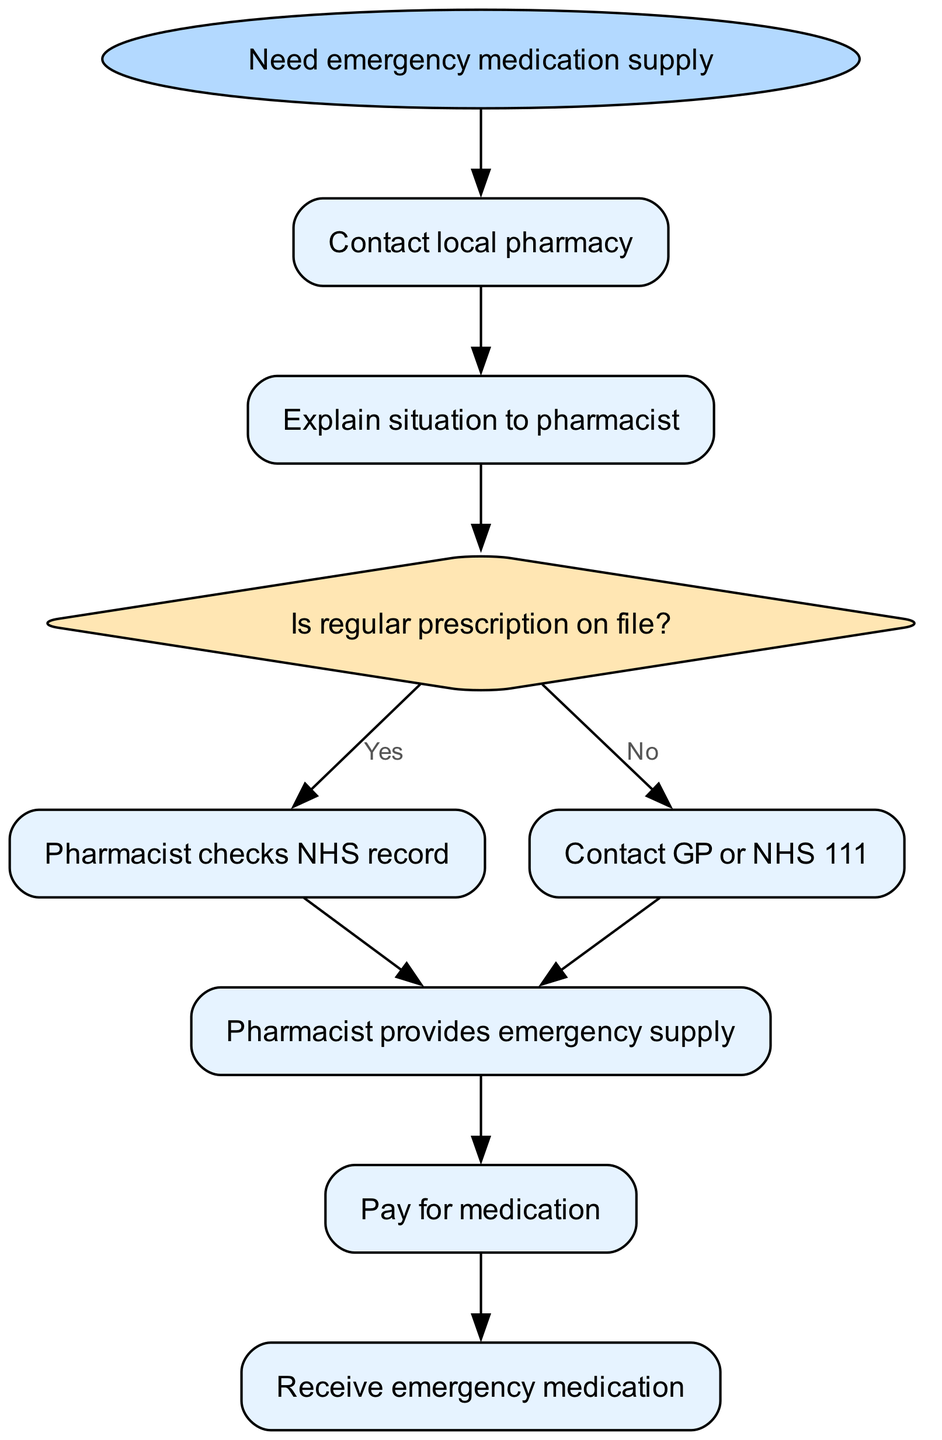What is the first step to take when needing an emergency medication supply? The first step in the diagram is represented by the "Need emergency medication supply" node. From this node, the next action is to "Contact local pharmacy."
Answer: Contact local pharmacy What type of shape represents a decision in the flow chart? In the flow chart, decisions are represented by diamond-shaped nodes, specifically labeled as "decision." In this case, the decision node is "Is regular prescription on file?"
Answer: Diamond How many steps are there in the process to obtain emergency medication? The process consists of six steps, starting from "Contact local pharmacy" and ending at "Pay for medication," followed by the final step "Receive emergency medication."
Answer: Six What action occurs if there is no regular prescription on file? If there is no regular prescription on file, the flow of the diagram indicates that the pharmacist should "Contact GP or NHS 111" to proceed with the emergency supply process.
Answer: Contact GP or NHS 111 What happens after the pharmacist provides the emergency supply? After the pharmacist provides the emergency supply, the next action in the flow chart is to "Pay for medication." This signifies that the patient must handle the financial aspect following the reception of the emergency supply.
Answer: Pay for medication If the regular prescription is on file, what does the pharmacist do next? If the regular prescription is on file, the pharmacist checks the NHS record to verify details and ensure the right medication can be supplied without issue. This is indicated as proceeding to "Pharmacist checks NHS record."
Answer: Pharmacist checks NHS record What is the last action taken in the flow after obtaining the medication? The final action in the flow chart is "Receive emergency medication." This concludes the entire procedure after payment has been made for the medication.
Answer: Receive emergency medication What would you do if the pharmacist cannot check the NHS record? If the pharmacist cannot check the NHS record, the flow indicates that the pharmacist will proceed to "Contact GP or NHS 111" for further assistance in supplying the medication.
Answer: Contact GP or NHS 111 How many edges connect the decision node to the next steps? There are two edges connecting the decision node "Is regular prescription on file?" to the next steps: one leading to "Pharmacist checks NHS record" and the other leading to "Contact GP or NHS 111." This represents the two possible outcomes based on the decision.
Answer: Two 